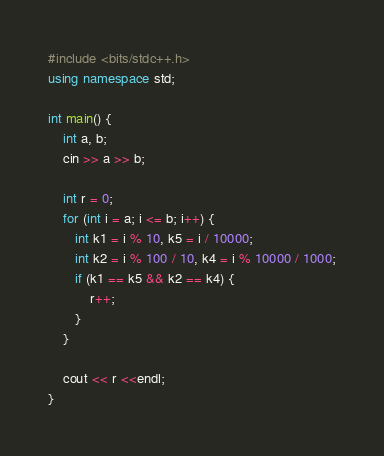<code> <loc_0><loc_0><loc_500><loc_500><_C++_>#include <bits/stdc++.h>
using namespace std;

int main() {
    int a, b;
    cin >> a >> b;
    
    int r = 0;
    for (int i = a; i <= b; i++) {
       int k1 = i % 10, k5 = i / 10000;
       int k2 = i % 100 / 10, k4 = i % 10000 / 1000;
       if (k1 == k5 && k2 == k4) {
           r++;
       }
    }
    
    cout << r <<endl;
}</code> 